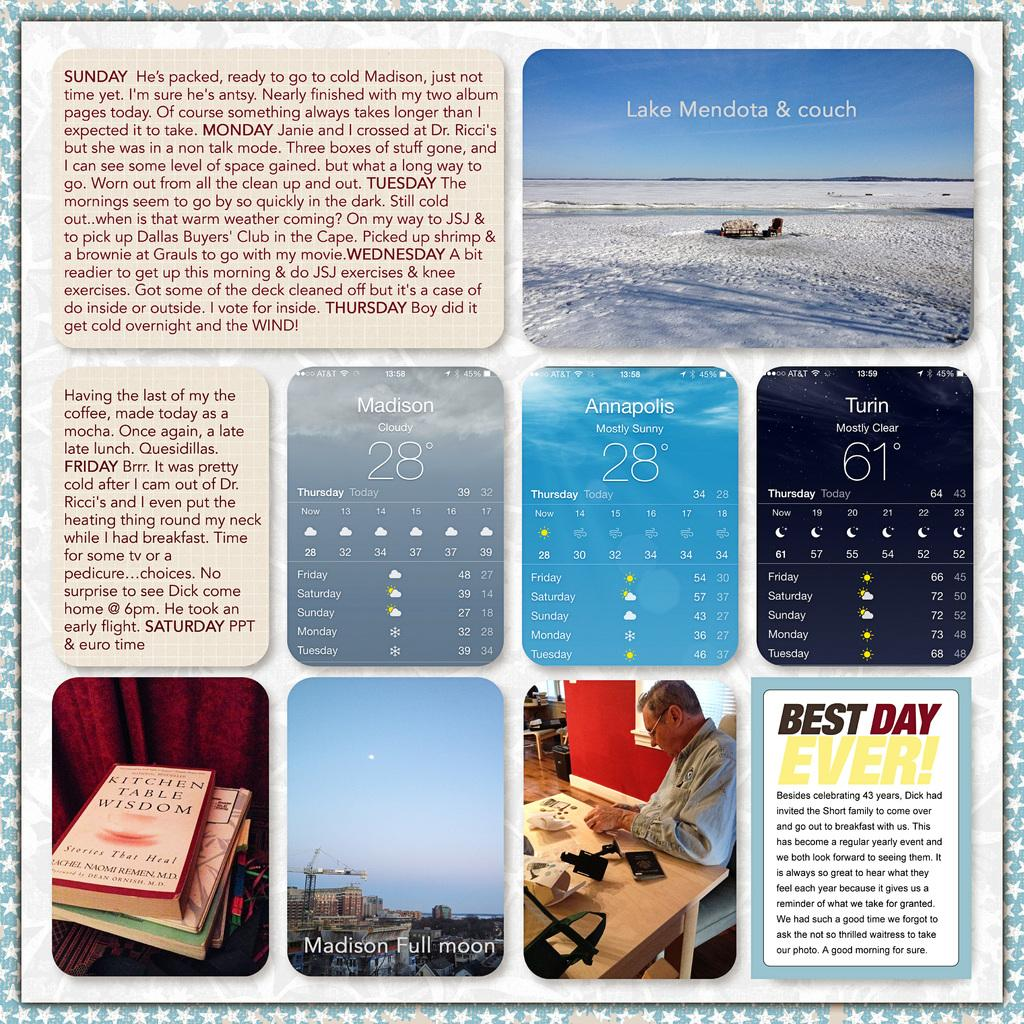<image>
Give a short and clear explanation of the subsequent image. A collection of different pictures featuring the weather, the Best Day Ever and other things. 